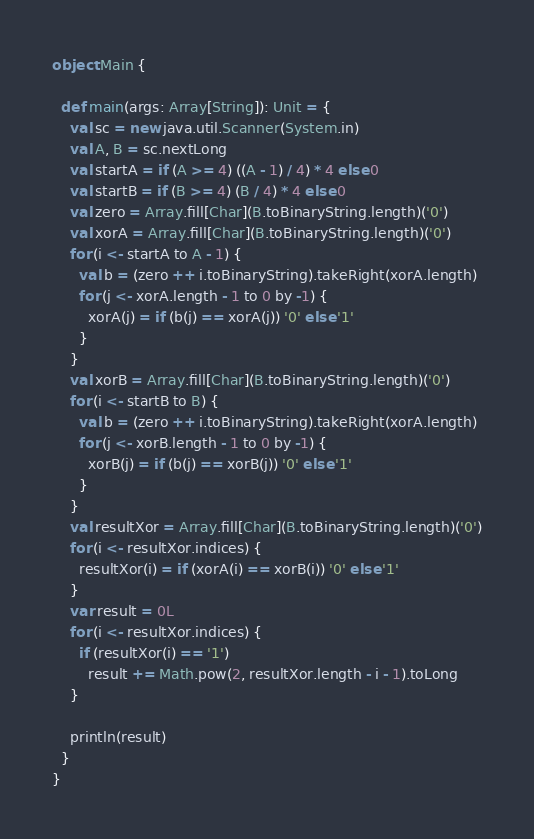Convert code to text. <code><loc_0><loc_0><loc_500><loc_500><_Scala_>object Main {

  def main(args: Array[String]): Unit = {
    val sc = new java.util.Scanner(System.in)
    val A, B = sc.nextLong
    val startA = if (A >= 4) ((A - 1) / 4) * 4 else 0
    val startB = if (B >= 4) (B / 4) * 4 else 0
    val zero = Array.fill[Char](B.toBinaryString.length)('0')
    val xorA = Array.fill[Char](B.toBinaryString.length)('0')
    for (i <- startA to A - 1) {
      val b = (zero ++ i.toBinaryString).takeRight(xorA.length)
      for (j <- xorA.length - 1 to 0 by -1) {
        xorA(j) = if (b(j) == xorA(j)) '0' else '1'
      }
    }
    val xorB = Array.fill[Char](B.toBinaryString.length)('0')
    for (i <- startB to B) {
      val b = (zero ++ i.toBinaryString).takeRight(xorA.length)
      for (j <- xorB.length - 1 to 0 by -1) {
        xorB(j) = if (b(j) == xorB(j)) '0' else '1'
      }
    }
    val resultXor = Array.fill[Char](B.toBinaryString.length)('0')
    for (i <- resultXor.indices) {
      resultXor(i) = if (xorA(i) == xorB(i)) '0' else '1'
    }
    var result = 0L
    for (i <- resultXor.indices) {
      if (resultXor(i) == '1')
        result += Math.pow(2, resultXor.length - i - 1).toLong
    }

    println(result)
  }
}</code> 